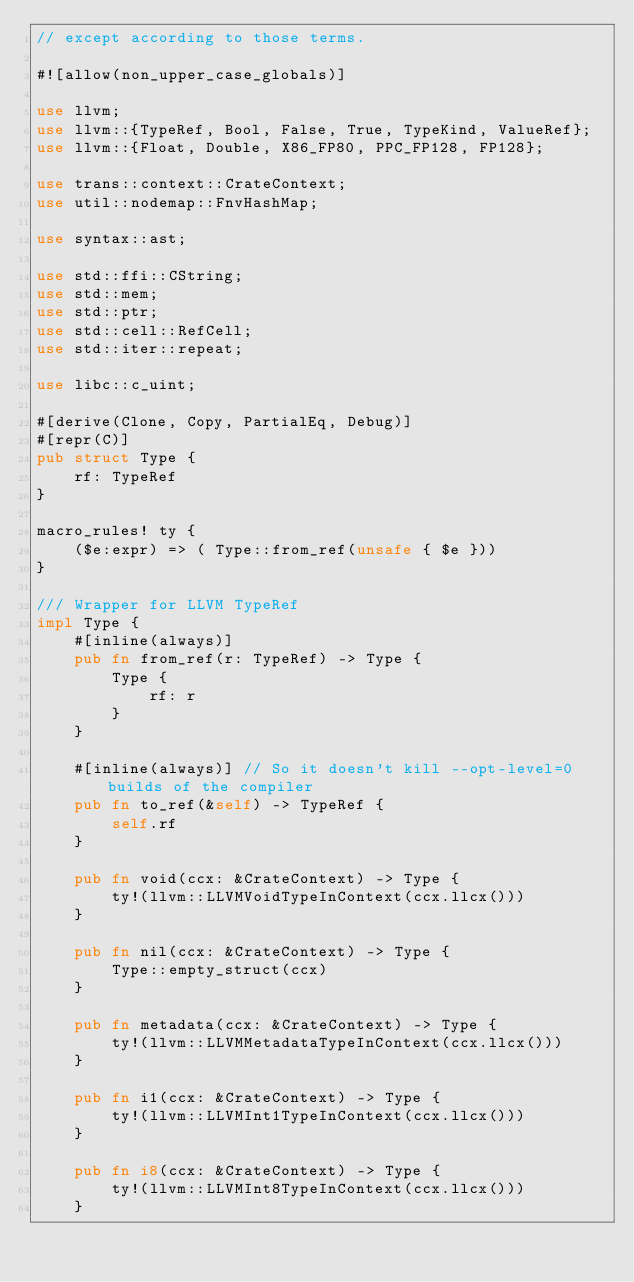Convert code to text. <code><loc_0><loc_0><loc_500><loc_500><_Rust_>// except according to those terms.

#![allow(non_upper_case_globals)]

use llvm;
use llvm::{TypeRef, Bool, False, True, TypeKind, ValueRef};
use llvm::{Float, Double, X86_FP80, PPC_FP128, FP128};

use trans::context::CrateContext;
use util::nodemap::FnvHashMap;

use syntax::ast;

use std::ffi::CString;
use std::mem;
use std::ptr;
use std::cell::RefCell;
use std::iter::repeat;

use libc::c_uint;

#[derive(Clone, Copy, PartialEq, Debug)]
#[repr(C)]
pub struct Type {
    rf: TypeRef
}

macro_rules! ty {
    ($e:expr) => ( Type::from_ref(unsafe { $e }))
}

/// Wrapper for LLVM TypeRef
impl Type {
    #[inline(always)]
    pub fn from_ref(r: TypeRef) -> Type {
        Type {
            rf: r
        }
    }

    #[inline(always)] // So it doesn't kill --opt-level=0 builds of the compiler
    pub fn to_ref(&self) -> TypeRef {
        self.rf
    }

    pub fn void(ccx: &CrateContext) -> Type {
        ty!(llvm::LLVMVoidTypeInContext(ccx.llcx()))
    }

    pub fn nil(ccx: &CrateContext) -> Type {
        Type::empty_struct(ccx)
    }

    pub fn metadata(ccx: &CrateContext) -> Type {
        ty!(llvm::LLVMMetadataTypeInContext(ccx.llcx()))
    }

    pub fn i1(ccx: &CrateContext) -> Type {
        ty!(llvm::LLVMInt1TypeInContext(ccx.llcx()))
    }

    pub fn i8(ccx: &CrateContext) -> Type {
        ty!(llvm::LLVMInt8TypeInContext(ccx.llcx()))
    }
</code> 